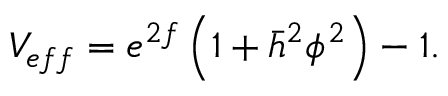<formula> <loc_0><loc_0><loc_500><loc_500>V _ { e f f } = e ^ { 2 f } \left ( 1 + \bar { h } ^ { 2 } \phi ^ { 2 } \right ) - 1 .</formula> 